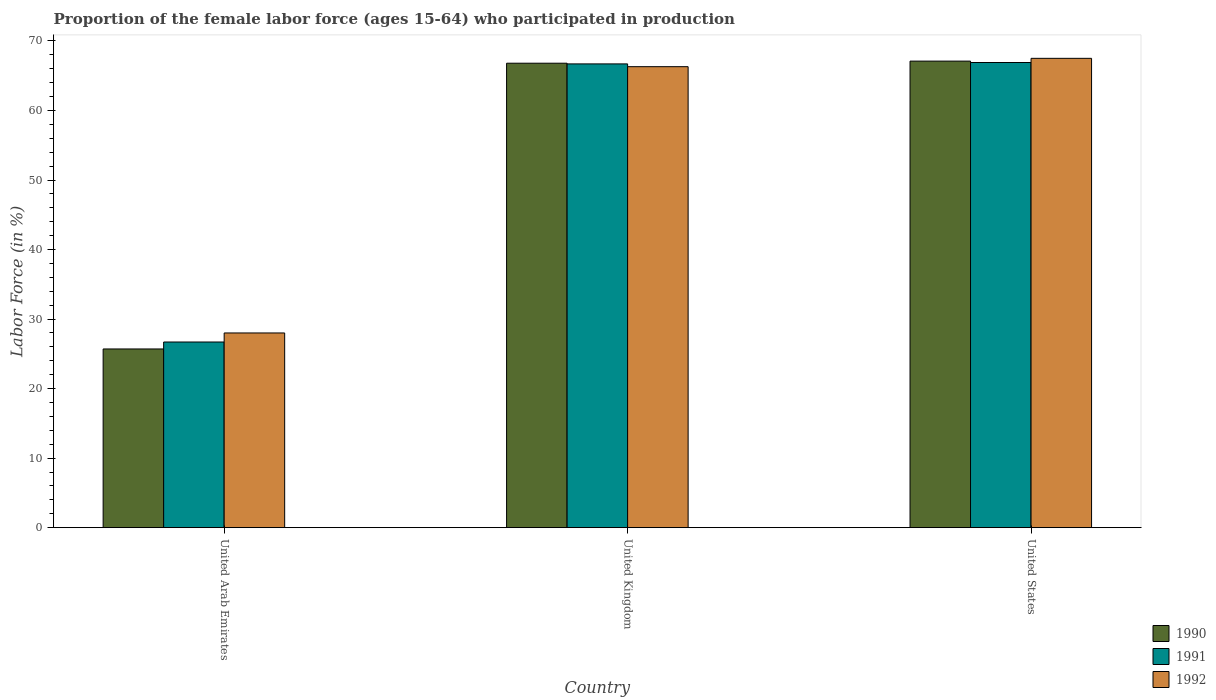Are the number of bars per tick equal to the number of legend labels?
Ensure brevity in your answer.  Yes. Are the number of bars on each tick of the X-axis equal?
Your answer should be compact. Yes. How many bars are there on the 3rd tick from the left?
Your response must be concise. 3. How many bars are there on the 3rd tick from the right?
Provide a succinct answer. 3. What is the label of the 1st group of bars from the left?
Give a very brief answer. United Arab Emirates. What is the proportion of the female labor force who participated in production in 1991 in United Kingdom?
Give a very brief answer. 66.7. Across all countries, what is the maximum proportion of the female labor force who participated in production in 1991?
Your answer should be very brief. 66.9. Across all countries, what is the minimum proportion of the female labor force who participated in production in 1991?
Give a very brief answer. 26.7. In which country was the proportion of the female labor force who participated in production in 1990 maximum?
Your answer should be very brief. United States. In which country was the proportion of the female labor force who participated in production in 1990 minimum?
Your response must be concise. United Arab Emirates. What is the total proportion of the female labor force who participated in production in 1990 in the graph?
Make the answer very short. 159.6. What is the difference between the proportion of the female labor force who participated in production in 1991 in United Arab Emirates and that in United States?
Offer a very short reply. -40.2. What is the difference between the proportion of the female labor force who participated in production in 1990 in United Arab Emirates and the proportion of the female labor force who participated in production in 1991 in United States?
Your answer should be compact. -41.2. What is the average proportion of the female labor force who participated in production in 1990 per country?
Your answer should be compact. 53.2. What is the difference between the proportion of the female labor force who participated in production of/in 1991 and proportion of the female labor force who participated in production of/in 1990 in United States?
Give a very brief answer. -0.2. What is the ratio of the proportion of the female labor force who participated in production in 1992 in United Kingdom to that in United States?
Your answer should be compact. 0.98. Is the proportion of the female labor force who participated in production in 1991 in United Kingdom less than that in United States?
Make the answer very short. Yes. What is the difference between the highest and the second highest proportion of the female labor force who participated in production in 1990?
Your response must be concise. -41.1. What is the difference between the highest and the lowest proportion of the female labor force who participated in production in 1992?
Offer a very short reply. 39.5. What does the 1st bar from the left in United States represents?
Give a very brief answer. 1990. Is it the case that in every country, the sum of the proportion of the female labor force who participated in production in 1992 and proportion of the female labor force who participated in production in 1991 is greater than the proportion of the female labor force who participated in production in 1990?
Offer a terse response. Yes. Are all the bars in the graph horizontal?
Offer a very short reply. No. Are the values on the major ticks of Y-axis written in scientific E-notation?
Make the answer very short. No. Where does the legend appear in the graph?
Give a very brief answer. Bottom right. How many legend labels are there?
Your response must be concise. 3. How are the legend labels stacked?
Your answer should be very brief. Vertical. What is the title of the graph?
Keep it short and to the point. Proportion of the female labor force (ages 15-64) who participated in production. Does "1994" appear as one of the legend labels in the graph?
Your answer should be very brief. No. What is the label or title of the X-axis?
Your answer should be compact. Country. What is the label or title of the Y-axis?
Keep it short and to the point. Labor Force (in %). What is the Labor Force (in %) in 1990 in United Arab Emirates?
Keep it short and to the point. 25.7. What is the Labor Force (in %) of 1991 in United Arab Emirates?
Your answer should be compact. 26.7. What is the Labor Force (in %) in 1990 in United Kingdom?
Provide a short and direct response. 66.8. What is the Labor Force (in %) in 1991 in United Kingdom?
Keep it short and to the point. 66.7. What is the Labor Force (in %) of 1992 in United Kingdom?
Your response must be concise. 66.3. What is the Labor Force (in %) in 1990 in United States?
Keep it short and to the point. 67.1. What is the Labor Force (in %) of 1991 in United States?
Ensure brevity in your answer.  66.9. What is the Labor Force (in %) in 1992 in United States?
Make the answer very short. 67.5. Across all countries, what is the maximum Labor Force (in %) of 1990?
Give a very brief answer. 67.1. Across all countries, what is the maximum Labor Force (in %) of 1991?
Provide a succinct answer. 66.9. Across all countries, what is the maximum Labor Force (in %) of 1992?
Provide a short and direct response. 67.5. Across all countries, what is the minimum Labor Force (in %) of 1990?
Your answer should be compact. 25.7. Across all countries, what is the minimum Labor Force (in %) in 1991?
Ensure brevity in your answer.  26.7. Across all countries, what is the minimum Labor Force (in %) of 1992?
Offer a terse response. 28. What is the total Labor Force (in %) in 1990 in the graph?
Give a very brief answer. 159.6. What is the total Labor Force (in %) of 1991 in the graph?
Keep it short and to the point. 160.3. What is the total Labor Force (in %) in 1992 in the graph?
Provide a succinct answer. 161.8. What is the difference between the Labor Force (in %) of 1990 in United Arab Emirates and that in United Kingdom?
Your response must be concise. -41.1. What is the difference between the Labor Force (in %) in 1992 in United Arab Emirates and that in United Kingdom?
Keep it short and to the point. -38.3. What is the difference between the Labor Force (in %) of 1990 in United Arab Emirates and that in United States?
Give a very brief answer. -41.4. What is the difference between the Labor Force (in %) of 1991 in United Arab Emirates and that in United States?
Your answer should be very brief. -40.2. What is the difference between the Labor Force (in %) of 1992 in United Arab Emirates and that in United States?
Your answer should be very brief. -39.5. What is the difference between the Labor Force (in %) of 1991 in United Kingdom and that in United States?
Make the answer very short. -0.2. What is the difference between the Labor Force (in %) of 1990 in United Arab Emirates and the Labor Force (in %) of 1991 in United Kingdom?
Your answer should be compact. -41. What is the difference between the Labor Force (in %) of 1990 in United Arab Emirates and the Labor Force (in %) of 1992 in United Kingdom?
Offer a terse response. -40.6. What is the difference between the Labor Force (in %) of 1991 in United Arab Emirates and the Labor Force (in %) of 1992 in United Kingdom?
Your answer should be compact. -39.6. What is the difference between the Labor Force (in %) of 1990 in United Arab Emirates and the Labor Force (in %) of 1991 in United States?
Provide a succinct answer. -41.2. What is the difference between the Labor Force (in %) of 1990 in United Arab Emirates and the Labor Force (in %) of 1992 in United States?
Offer a very short reply. -41.8. What is the difference between the Labor Force (in %) in 1991 in United Arab Emirates and the Labor Force (in %) in 1992 in United States?
Ensure brevity in your answer.  -40.8. What is the difference between the Labor Force (in %) in 1990 in United Kingdom and the Labor Force (in %) in 1991 in United States?
Your answer should be very brief. -0.1. What is the difference between the Labor Force (in %) of 1990 in United Kingdom and the Labor Force (in %) of 1992 in United States?
Offer a very short reply. -0.7. What is the difference between the Labor Force (in %) of 1991 in United Kingdom and the Labor Force (in %) of 1992 in United States?
Offer a terse response. -0.8. What is the average Labor Force (in %) in 1990 per country?
Your answer should be compact. 53.2. What is the average Labor Force (in %) of 1991 per country?
Your response must be concise. 53.43. What is the average Labor Force (in %) of 1992 per country?
Offer a terse response. 53.93. What is the difference between the Labor Force (in %) in 1990 and Labor Force (in %) in 1991 in United Kingdom?
Your response must be concise. 0.1. What is the difference between the Labor Force (in %) in 1990 and Labor Force (in %) in 1991 in United States?
Offer a very short reply. 0.2. What is the difference between the Labor Force (in %) in 1991 and Labor Force (in %) in 1992 in United States?
Offer a very short reply. -0.6. What is the ratio of the Labor Force (in %) of 1990 in United Arab Emirates to that in United Kingdom?
Provide a short and direct response. 0.38. What is the ratio of the Labor Force (in %) of 1991 in United Arab Emirates to that in United Kingdom?
Your answer should be very brief. 0.4. What is the ratio of the Labor Force (in %) of 1992 in United Arab Emirates to that in United Kingdom?
Ensure brevity in your answer.  0.42. What is the ratio of the Labor Force (in %) of 1990 in United Arab Emirates to that in United States?
Your answer should be compact. 0.38. What is the ratio of the Labor Force (in %) of 1991 in United Arab Emirates to that in United States?
Offer a very short reply. 0.4. What is the ratio of the Labor Force (in %) of 1992 in United Arab Emirates to that in United States?
Provide a short and direct response. 0.41. What is the ratio of the Labor Force (in %) in 1990 in United Kingdom to that in United States?
Ensure brevity in your answer.  1. What is the ratio of the Labor Force (in %) in 1992 in United Kingdom to that in United States?
Offer a very short reply. 0.98. What is the difference between the highest and the second highest Labor Force (in %) in 1990?
Provide a short and direct response. 0.3. What is the difference between the highest and the second highest Labor Force (in %) in 1992?
Your answer should be compact. 1.2. What is the difference between the highest and the lowest Labor Force (in %) of 1990?
Provide a short and direct response. 41.4. What is the difference between the highest and the lowest Labor Force (in %) of 1991?
Your answer should be very brief. 40.2. What is the difference between the highest and the lowest Labor Force (in %) in 1992?
Ensure brevity in your answer.  39.5. 